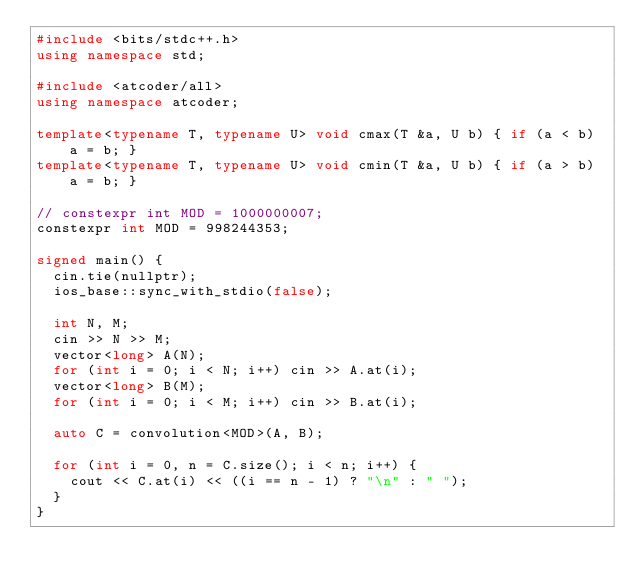<code> <loc_0><loc_0><loc_500><loc_500><_C++_>#include <bits/stdc++.h>
using namespace std;

#include <atcoder/all>
using namespace atcoder;

template<typename T, typename U> void cmax(T &a, U b) { if (a < b) a = b; }
template<typename T, typename U> void cmin(T &a, U b) { if (a > b) a = b; }

// constexpr int MOD = 1000000007;
constexpr int MOD = 998244353;

signed main() {
  cin.tie(nullptr);
  ios_base::sync_with_stdio(false);

  int N, M;
  cin >> N >> M;
  vector<long> A(N);
  for (int i = 0; i < N; i++) cin >> A.at(i);
  vector<long> B(M);
  for (int i = 0; i < M; i++) cin >> B.at(i);

  auto C = convolution<MOD>(A, B);

  for (int i = 0, n = C.size(); i < n; i++) {
    cout << C.at(i) << ((i == n - 1) ? "\n" : " ");
  }
}</code> 